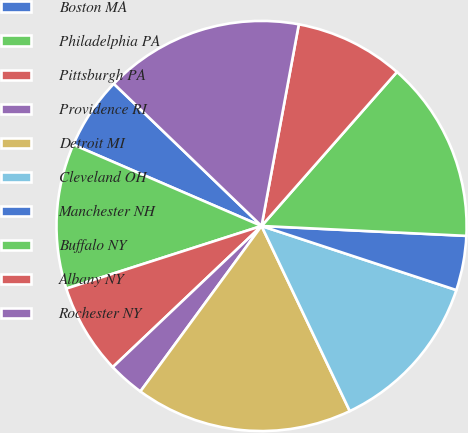<chart> <loc_0><loc_0><loc_500><loc_500><pie_chart><fcel>Boston MA<fcel>Philadelphia PA<fcel>Pittsburgh PA<fcel>Providence RI<fcel>Detroit MI<fcel>Cleveland OH<fcel>Manchester NH<fcel>Buffalo NY<fcel>Albany NY<fcel>Rochester NY<nl><fcel>5.71%<fcel>11.43%<fcel>7.14%<fcel>2.86%<fcel>17.14%<fcel>12.86%<fcel>4.29%<fcel>14.29%<fcel>8.57%<fcel>15.71%<nl></chart> 